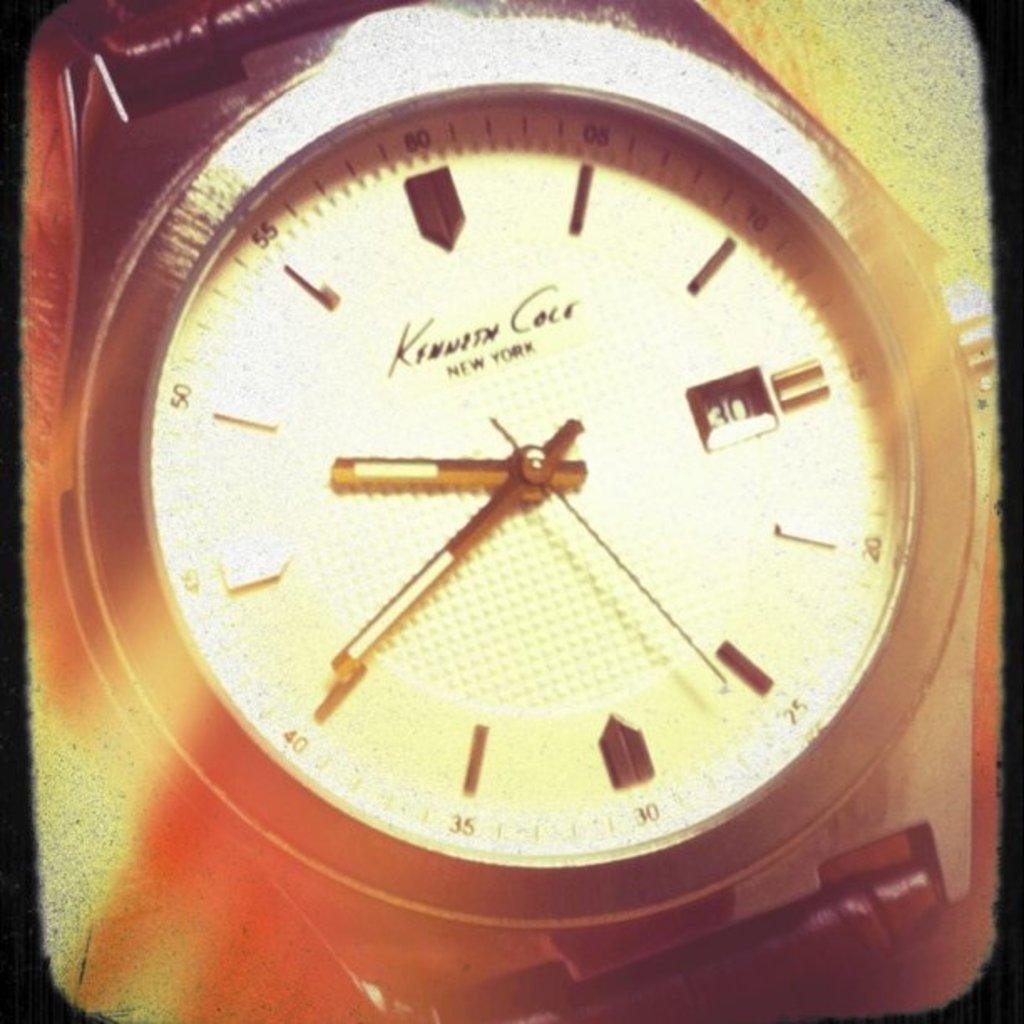In one or two sentences, can you explain what this image depicts? In this picture, we see a wrist watch. In the background, it is in yellow and orange color. This picture might be a photo frame or it might be an edited image. 